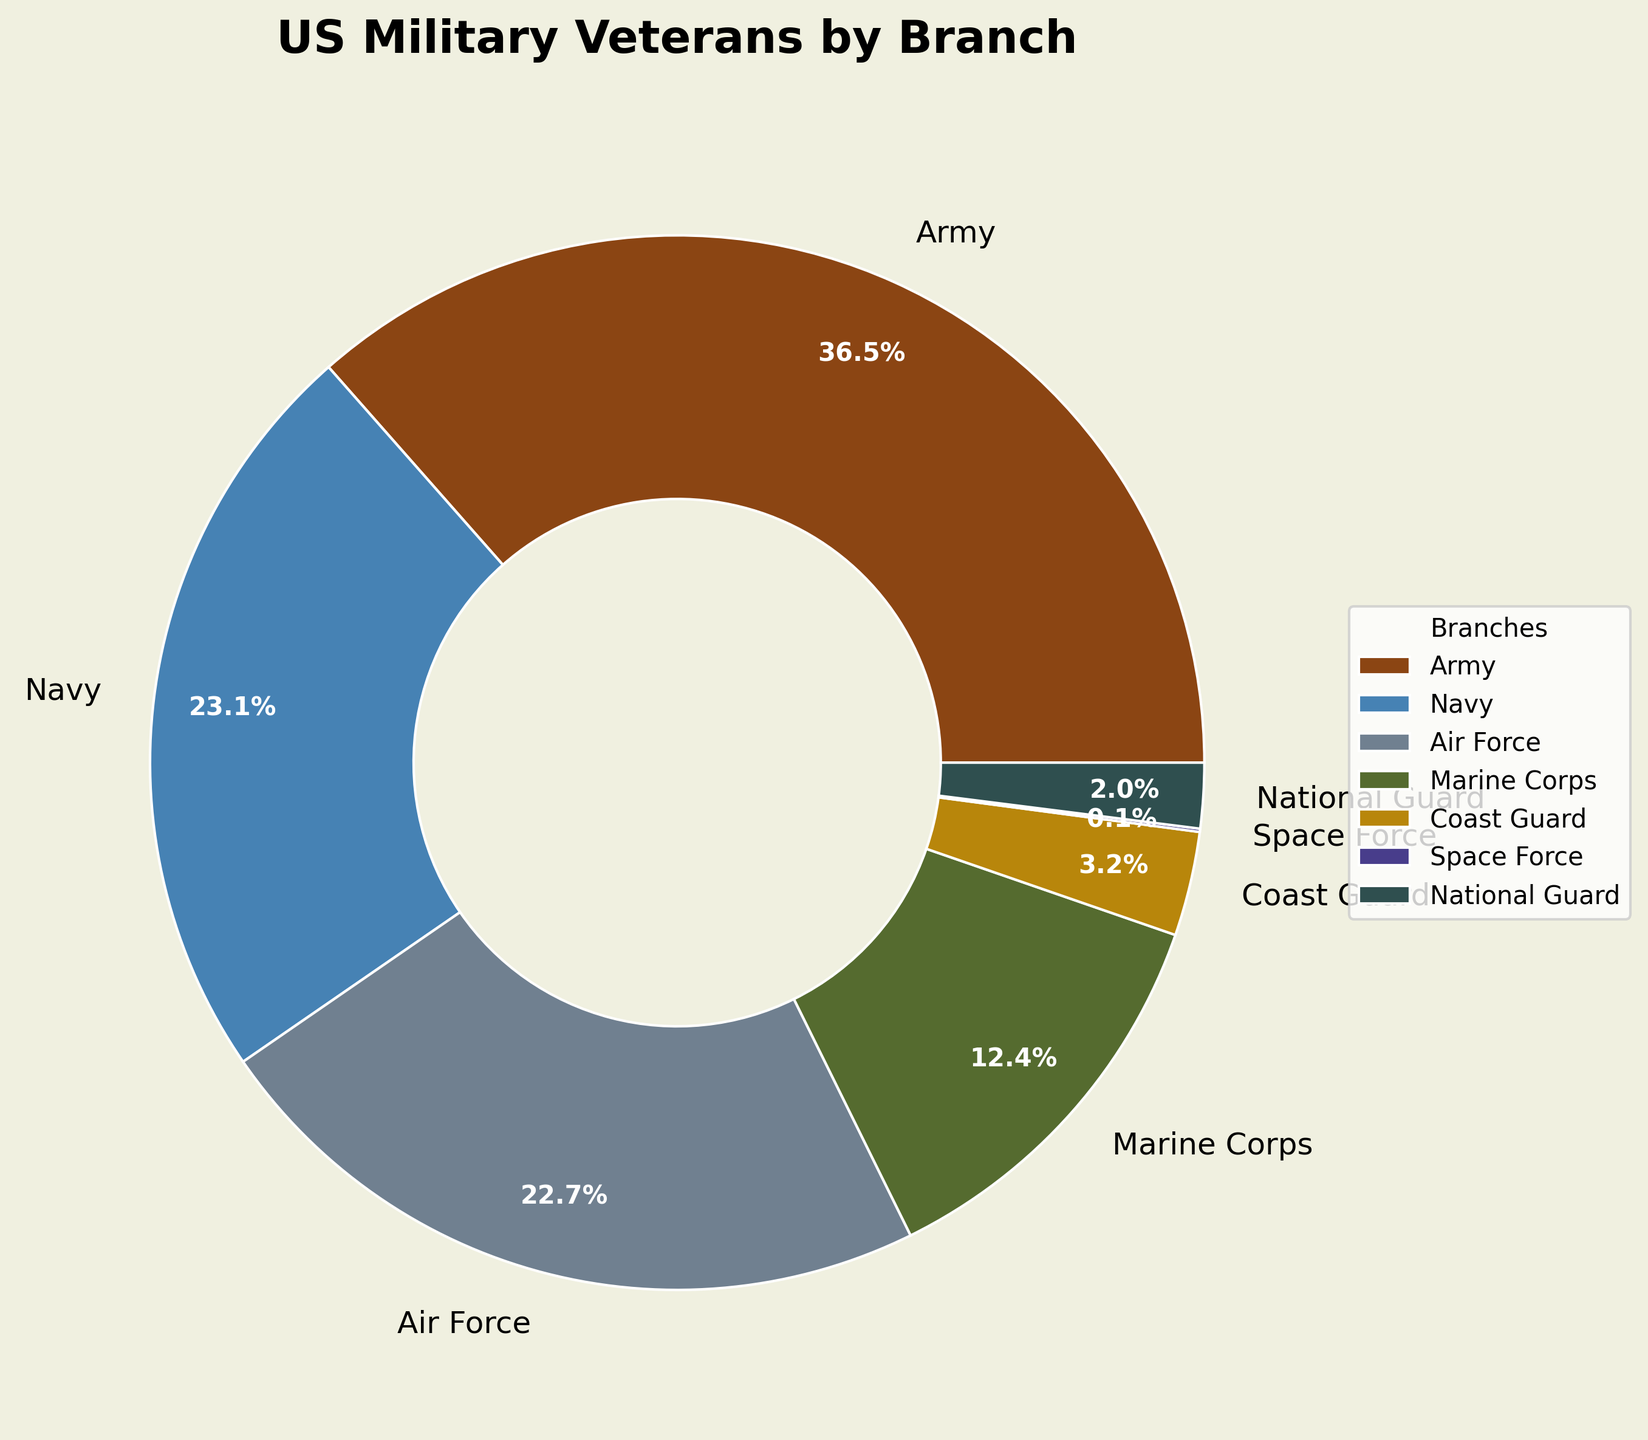What percentage of US veterans served in the Marine Corps? Look at the section of the pie chart labeled "Marine Corps" and note the percentage value shown there.
Answer: 12.4% Which branch has a higher percentage of veterans, the Air Force or the Navy? Compare the percentages shown for the Air Force and the Navy. The Navy has 23.1% while the Air Force has 22.7%.
Answer: Navy How many percentage points more veterans served in the Army compared to the Coast Guard? Subtract the percentage for the Coast Guard from the percentage for the Army (36.5% - 3.2%).
Answer: 33.3 What is the combined percentage of veterans who served in the Army and the Navy? Add the percentages for the Army and Navy (36.5% + 23.1%).
Answer: 59.6% Which branches have a combined percentage less than 10%? Identify branches whose percentages sum to less than 10%. The Coast Guard (3.2%), Space Force (0.1%), and National Guard (2.0%) together sum to 5.3%.
Answer: Coast Guard, Space Force, National Guard Which branch has the smallest percentage of US veterans, and what is that percentage? Look for the branch with the smallest slice in the pie chart, labeled Space Force, with a percentage of 0.1%.
Answer: Space Force, 0.1% What is the visual cue indicating the branch with the largest percentage of veterans? The Army section is the largest slice of the pie chart.
Answer: Army How much more prominent visually is the Army slice compared to the Marine Corps slice in terms of percentage points? Subtract the Marine Corps percentage (12.4%) from the Army percentage (36.5%).
Answer: 24.1 What percentage of veterans served in branches other than the Army? Subtract the percentage of the Army from 100% (100% - 36.5%).
Answer: 63.5% What is the difference in veteran representation between the National Guard and the Space Force? Subtract the Space Force percentage from the National Guard percentage (2.0% - 0.1%).
Answer: 1.9 